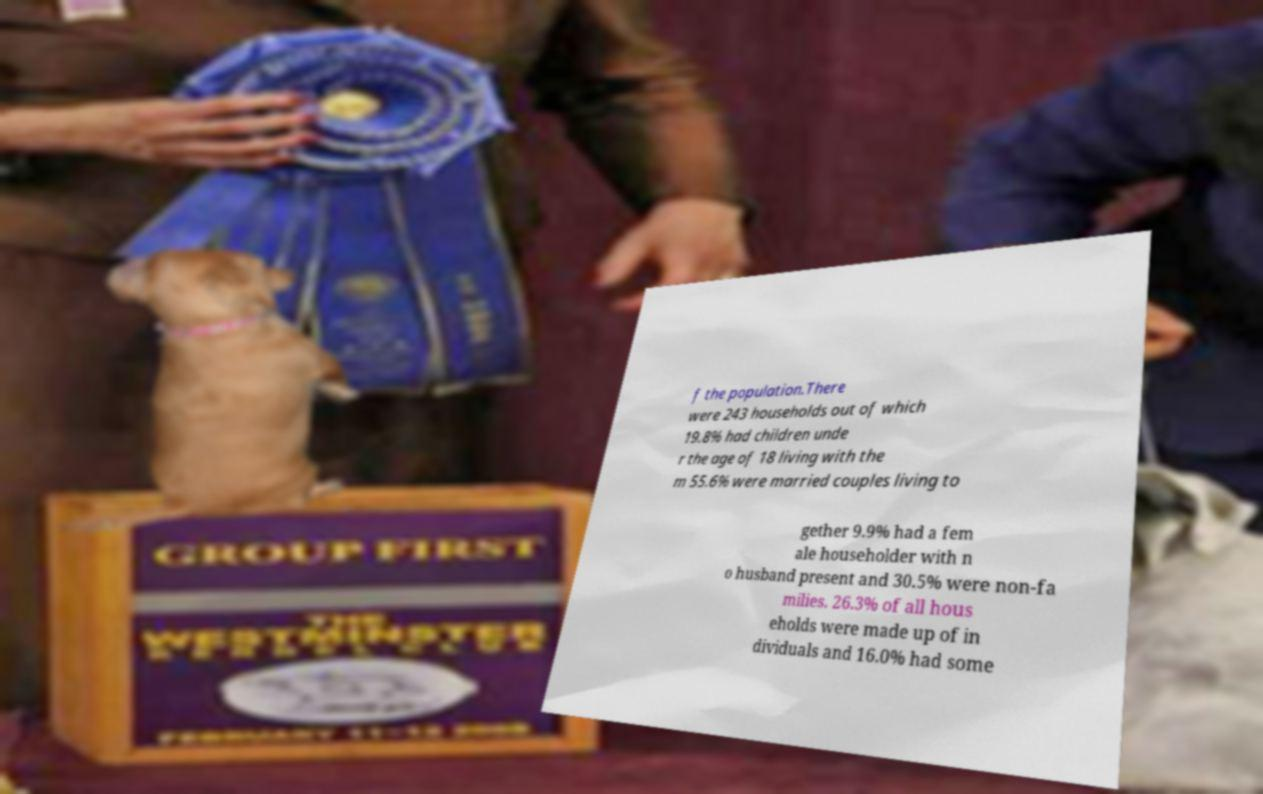What messages or text are displayed in this image? I need them in a readable, typed format. f the population.There were 243 households out of which 19.8% had children unde r the age of 18 living with the m 55.6% were married couples living to gether 9.9% had a fem ale householder with n o husband present and 30.5% were non-fa milies. 26.3% of all hous eholds were made up of in dividuals and 16.0% had some 